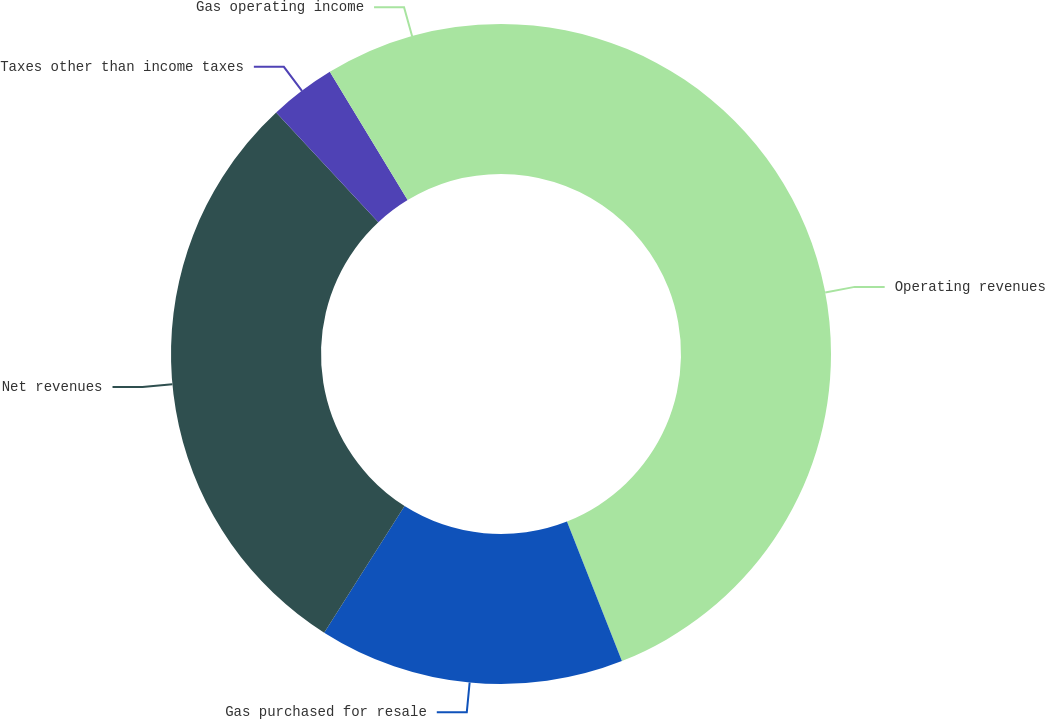<chart> <loc_0><loc_0><loc_500><loc_500><pie_chart><fcel>Operating revenues<fcel>Gas purchased for resale<fcel>Net revenues<fcel>Taxes other than income taxes<fcel>Gas operating income<nl><fcel>44.03%<fcel>14.97%<fcel>29.07%<fcel>3.25%<fcel>8.68%<nl></chart> 